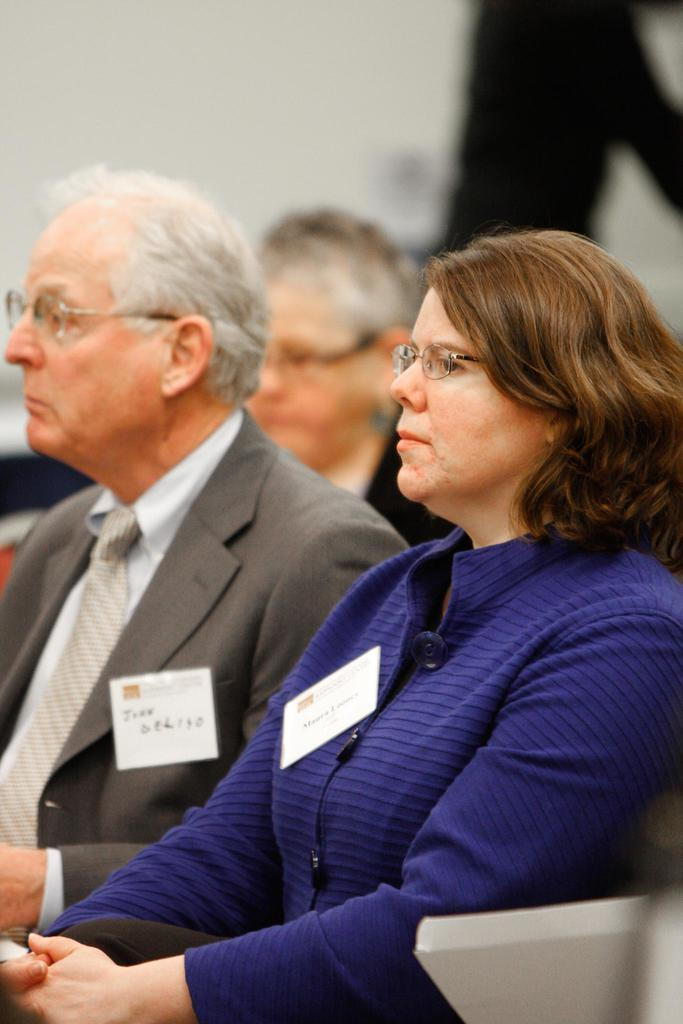How many people are in the image? There are three persons sitting in the center of the image. What can be seen behind the people in the image? There is a wall at the top of the image. What type of dinosaur can be seen in the image? There are no dinosaurs present in the image. What songs are being sung by the people in the image? There is no information about songs being sung in the image. 